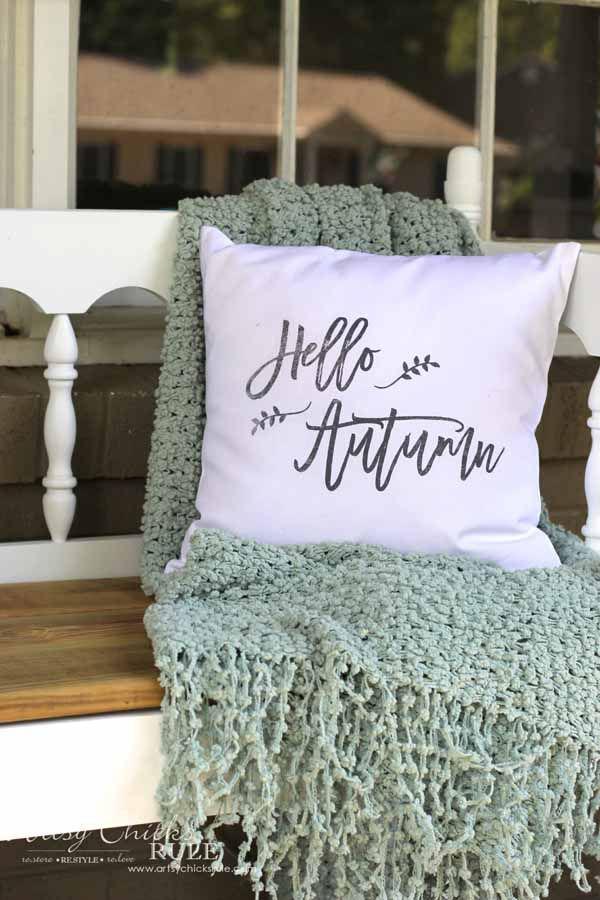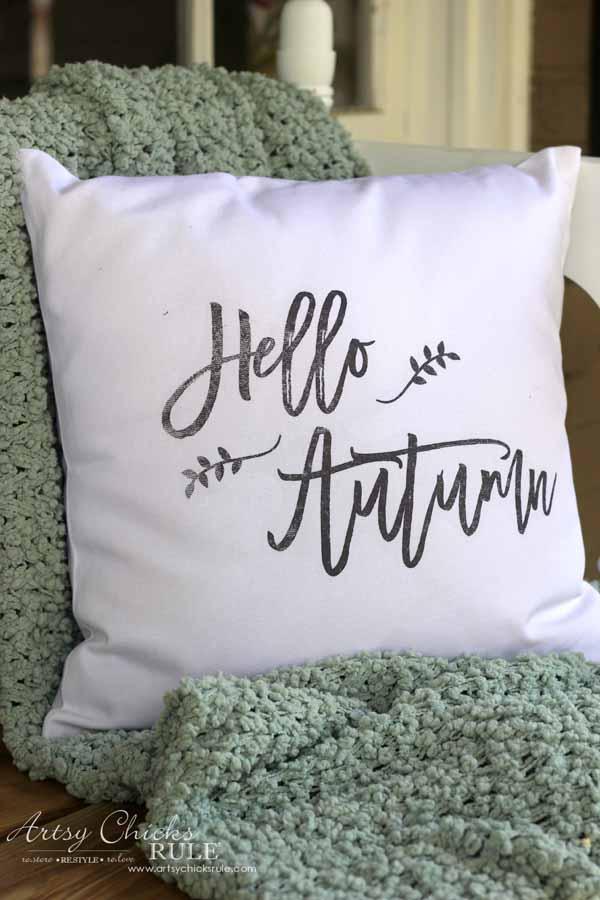The first image is the image on the left, the second image is the image on the right. For the images shown, is this caption "Two pillows with writing on them." true? Answer yes or no. Yes. The first image is the image on the left, the second image is the image on the right. Assess this claim about the two images: "There is at least one throw blanket under at least one pillow.". Correct or not? Answer yes or no. Yes. 